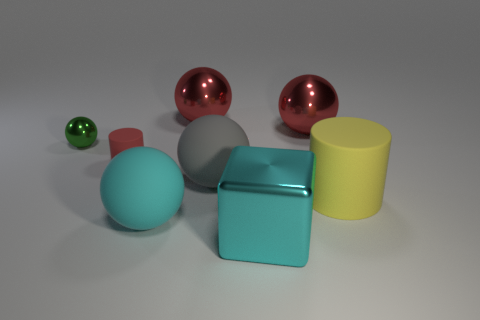Subtract all cyan balls. How many balls are left? 4 Subtract all purple balls. Subtract all green cylinders. How many balls are left? 5 Add 1 small things. How many objects exist? 9 Subtract all cylinders. How many objects are left? 6 Subtract all brown things. Subtract all cyan spheres. How many objects are left? 7 Add 2 red cylinders. How many red cylinders are left? 3 Add 2 large rubber things. How many large rubber things exist? 5 Subtract 1 red cylinders. How many objects are left? 7 